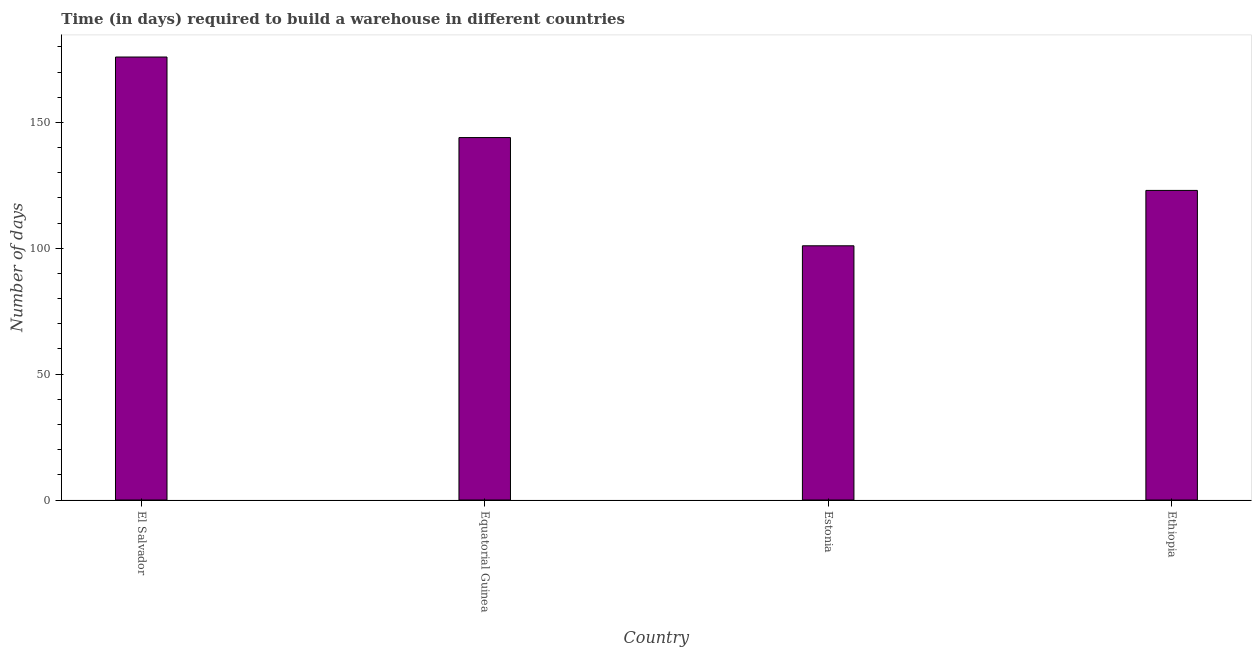Does the graph contain grids?
Provide a short and direct response. No. What is the title of the graph?
Offer a terse response. Time (in days) required to build a warehouse in different countries. What is the label or title of the X-axis?
Your answer should be compact. Country. What is the label or title of the Y-axis?
Your response must be concise. Number of days. What is the time required to build a warehouse in Estonia?
Ensure brevity in your answer.  101. Across all countries, what is the maximum time required to build a warehouse?
Your response must be concise. 176. Across all countries, what is the minimum time required to build a warehouse?
Ensure brevity in your answer.  101. In which country was the time required to build a warehouse maximum?
Ensure brevity in your answer.  El Salvador. In which country was the time required to build a warehouse minimum?
Ensure brevity in your answer.  Estonia. What is the sum of the time required to build a warehouse?
Provide a short and direct response. 544. What is the difference between the time required to build a warehouse in El Salvador and Ethiopia?
Keep it short and to the point. 53. What is the average time required to build a warehouse per country?
Make the answer very short. 136. What is the median time required to build a warehouse?
Give a very brief answer. 133.5. What is the ratio of the time required to build a warehouse in El Salvador to that in Estonia?
Provide a succinct answer. 1.74. How many bars are there?
Your answer should be very brief. 4. How many countries are there in the graph?
Ensure brevity in your answer.  4. Are the values on the major ticks of Y-axis written in scientific E-notation?
Keep it short and to the point. No. What is the Number of days in El Salvador?
Make the answer very short. 176. What is the Number of days of Equatorial Guinea?
Your answer should be compact. 144. What is the Number of days in Estonia?
Provide a succinct answer. 101. What is the Number of days in Ethiopia?
Your answer should be compact. 123. What is the difference between the Number of days in El Salvador and Ethiopia?
Offer a terse response. 53. What is the difference between the Number of days in Equatorial Guinea and Estonia?
Provide a succinct answer. 43. What is the difference between the Number of days in Estonia and Ethiopia?
Your response must be concise. -22. What is the ratio of the Number of days in El Salvador to that in Equatorial Guinea?
Offer a terse response. 1.22. What is the ratio of the Number of days in El Salvador to that in Estonia?
Give a very brief answer. 1.74. What is the ratio of the Number of days in El Salvador to that in Ethiopia?
Your response must be concise. 1.43. What is the ratio of the Number of days in Equatorial Guinea to that in Estonia?
Provide a succinct answer. 1.43. What is the ratio of the Number of days in Equatorial Guinea to that in Ethiopia?
Your answer should be compact. 1.17. What is the ratio of the Number of days in Estonia to that in Ethiopia?
Keep it short and to the point. 0.82. 